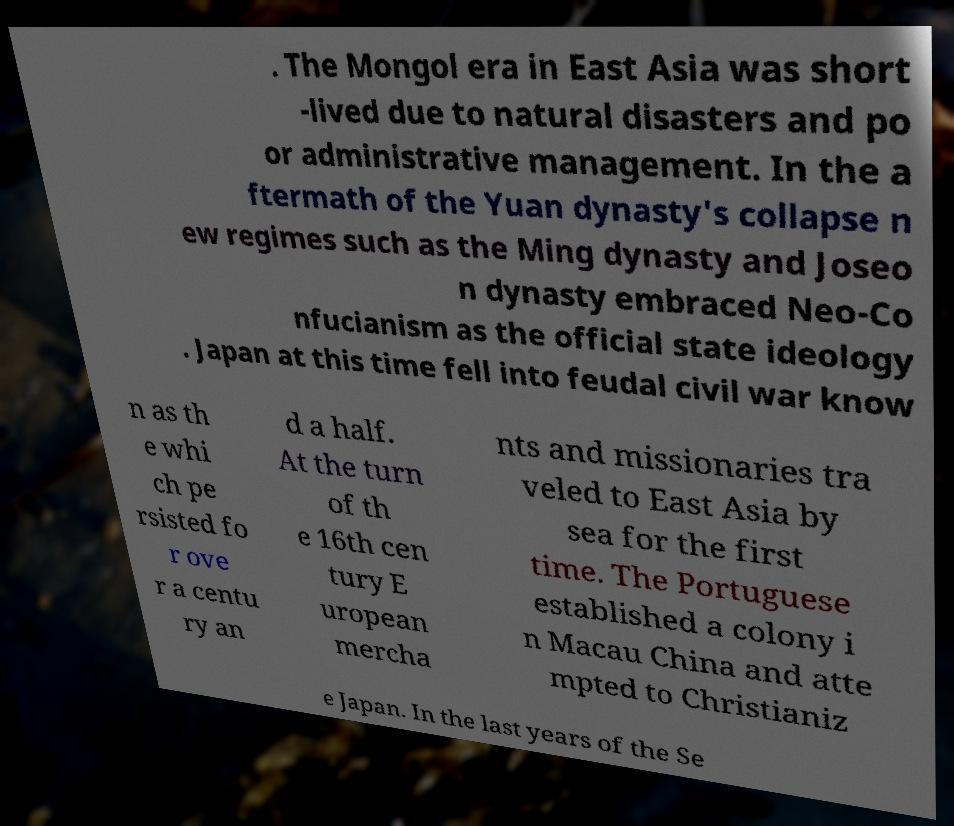Please read and relay the text visible in this image. What does it say? . The Mongol era in East Asia was short -lived due to natural disasters and po or administrative management. In the a ftermath of the Yuan dynasty's collapse n ew regimes such as the Ming dynasty and Joseo n dynasty embraced Neo-Co nfucianism as the official state ideology . Japan at this time fell into feudal civil war know n as th e whi ch pe rsisted fo r ove r a centu ry an d a half. At the turn of th e 16th cen tury E uropean mercha nts and missionaries tra veled to East Asia by sea for the first time. The Portuguese established a colony i n Macau China and atte mpted to Christianiz e Japan. In the last years of the Se 